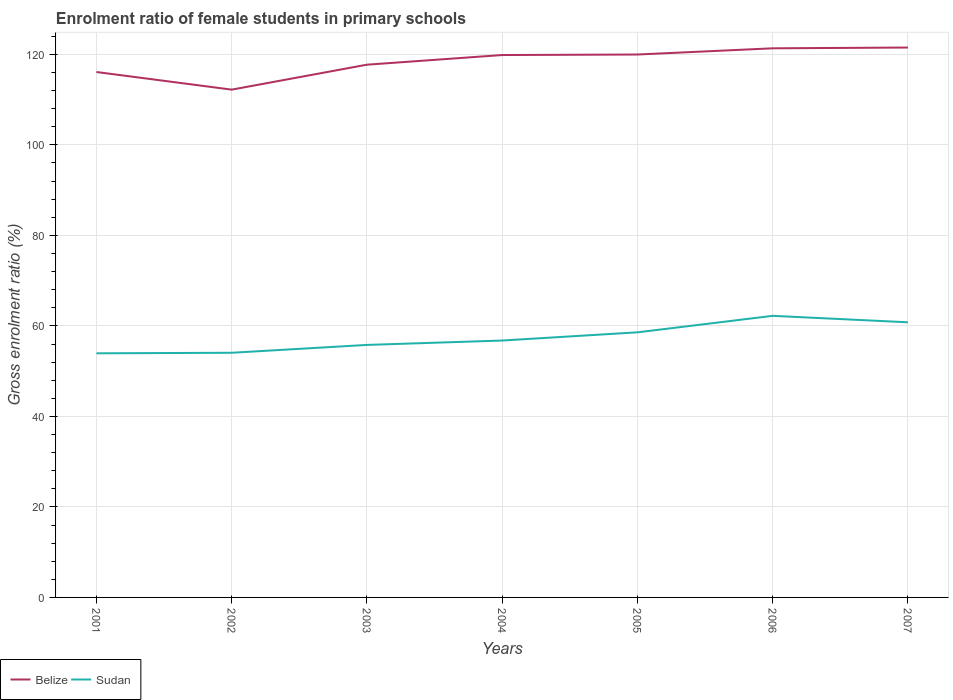Is the number of lines equal to the number of legend labels?
Provide a short and direct response. Yes. Across all years, what is the maximum enrolment ratio of female students in primary schools in Sudan?
Your response must be concise. 53.94. What is the total enrolment ratio of female students in primary schools in Sudan in the graph?
Keep it short and to the point. -4.52. What is the difference between the highest and the second highest enrolment ratio of female students in primary schools in Belize?
Your answer should be compact. 9.3. Is the enrolment ratio of female students in primary schools in Sudan strictly greater than the enrolment ratio of female students in primary schools in Belize over the years?
Your response must be concise. Yes. How many lines are there?
Keep it short and to the point. 2. Are the values on the major ticks of Y-axis written in scientific E-notation?
Offer a terse response. No. What is the title of the graph?
Your answer should be very brief. Enrolment ratio of female students in primary schools. What is the label or title of the X-axis?
Offer a terse response. Years. What is the Gross enrolment ratio (%) in Belize in 2001?
Keep it short and to the point. 116.11. What is the Gross enrolment ratio (%) of Sudan in 2001?
Keep it short and to the point. 53.94. What is the Gross enrolment ratio (%) in Belize in 2002?
Ensure brevity in your answer.  112.21. What is the Gross enrolment ratio (%) of Sudan in 2002?
Provide a short and direct response. 54.06. What is the Gross enrolment ratio (%) in Belize in 2003?
Your answer should be compact. 117.72. What is the Gross enrolment ratio (%) in Sudan in 2003?
Give a very brief answer. 55.8. What is the Gross enrolment ratio (%) of Belize in 2004?
Your response must be concise. 119.86. What is the Gross enrolment ratio (%) in Sudan in 2004?
Offer a terse response. 56.77. What is the Gross enrolment ratio (%) of Belize in 2005?
Give a very brief answer. 119.97. What is the Gross enrolment ratio (%) of Sudan in 2005?
Give a very brief answer. 58.58. What is the Gross enrolment ratio (%) of Belize in 2006?
Provide a succinct answer. 121.34. What is the Gross enrolment ratio (%) in Sudan in 2006?
Your answer should be very brief. 62.23. What is the Gross enrolment ratio (%) in Belize in 2007?
Offer a very short reply. 121.51. What is the Gross enrolment ratio (%) of Sudan in 2007?
Your response must be concise. 60.8. Across all years, what is the maximum Gross enrolment ratio (%) of Belize?
Your answer should be very brief. 121.51. Across all years, what is the maximum Gross enrolment ratio (%) of Sudan?
Your response must be concise. 62.23. Across all years, what is the minimum Gross enrolment ratio (%) in Belize?
Keep it short and to the point. 112.21. Across all years, what is the minimum Gross enrolment ratio (%) in Sudan?
Provide a short and direct response. 53.94. What is the total Gross enrolment ratio (%) in Belize in the graph?
Ensure brevity in your answer.  828.72. What is the total Gross enrolment ratio (%) in Sudan in the graph?
Your answer should be compact. 402.18. What is the difference between the Gross enrolment ratio (%) in Belize in 2001 and that in 2002?
Keep it short and to the point. 3.9. What is the difference between the Gross enrolment ratio (%) of Sudan in 2001 and that in 2002?
Your response must be concise. -0.12. What is the difference between the Gross enrolment ratio (%) of Belize in 2001 and that in 2003?
Make the answer very short. -1.62. What is the difference between the Gross enrolment ratio (%) in Sudan in 2001 and that in 2003?
Provide a succinct answer. -1.86. What is the difference between the Gross enrolment ratio (%) in Belize in 2001 and that in 2004?
Give a very brief answer. -3.75. What is the difference between the Gross enrolment ratio (%) of Sudan in 2001 and that in 2004?
Make the answer very short. -2.83. What is the difference between the Gross enrolment ratio (%) in Belize in 2001 and that in 2005?
Your response must be concise. -3.86. What is the difference between the Gross enrolment ratio (%) of Sudan in 2001 and that in 2005?
Give a very brief answer. -4.64. What is the difference between the Gross enrolment ratio (%) of Belize in 2001 and that in 2006?
Your answer should be very brief. -5.23. What is the difference between the Gross enrolment ratio (%) of Sudan in 2001 and that in 2006?
Provide a short and direct response. -8.28. What is the difference between the Gross enrolment ratio (%) of Belize in 2001 and that in 2007?
Your response must be concise. -5.41. What is the difference between the Gross enrolment ratio (%) in Sudan in 2001 and that in 2007?
Offer a terse response. -6.86. What is the difference between the Gross enrolment ratio (%) in Belize in 2002 and that in 2003?
Provide a short and direct response. -5.51. What is the difference between the Gross enrolment ratio (%) in Sudan in 2002 and that in 2003?
Keep it short and to the point. -1.73. What is the difference between the Gross enrolment ratio (%) of Belize in 2002 and that in 2004?
Your answer should be compact. -7.65. What is the difference between the Gross enrolment ratio (%) in Sudan in 2002 and that in 2004?
Keep it short and to the point. -2.7. What is the difference between the Gross enrolment ratio (%) in Belize in 2002 and that in 2005?
Offer a terse response. -7.76. What is the difference between the Gross enrolment ratio (%) of Sudan in 2002 and that in 2005?
Your response must be concise. -4.52. What is the difference between the Gross enrolment ratio (%) of Belize in 2002 and that in 2006?
Ensure brevity in your answer.  -9.13. What is the difference between the Gross enrolment ratio (%) in Sudan in 2002 and that in 2006?
Your answer should be very brief. -8.16. What is the difference between the Gross enrolment ratio (%) of Belize in 2002 and that in 2007?
Offer a very short reply. -9.3. What is the difference between the Gross enrolment ratio (%) of Sudan in 2002 and that in 2007?
Your answer should be compact. -6.73. What is the difference between the Gross enrolment ratio (%) of Belize in 2003 and that in 2004?
Your answer should be very brief. -2.14. What is the difference between the Gross enrolment ratio (%) in Sudan in 2003 and that in 2004?
Offer a terse response. -0.97. What is the difference between the Gross enrolment ratio (%) in Belize in 2003 and that in 2005?
Give a very brief answer. -2.25. What is the difference between the Gross enrolment ratio (%) in Sudan in 2003 and that in 2005?
Give a very brief answer. -2.78. What is the difference between the Gross enrolment ratio (%) in Belize in 2003 and that in 2006?
Your answer should be very brief. -3.62. What is the difference between the Gross enrolment ratio (%) of Sudan in 2003 and that in 2006?
Ensure brevity in your answer.  -6.43. What is the difference between the Gross enrolment ratio (%) of Belize in 2003 and that in 2007?
Make the answer very short. -3.79. What is the difference between the Gross enrolment ratio (%) of Sudan in 2003 and that in 2007?
Give a very brief answer. -5. What is the difference between the Gross enrolment ratio (%) in Belize in 2004 and that in 2005?
Provide a succinct answer. -0.11. What is the difference between the Gross enrolment ratio (%) of Sudan in 2004 and that in 2005?
Offer a terse response. -1.81. What is the difference between the Gross enrolment ratio (%) of Belize in 2004 and that in 2006?
Provide a succinct answer. -1.48. What is the difference between the Gross enrolment ratio (%) of Sudan in 2004 and that in 2006?
Keep it short and to the point. -5.46. What is the difference between the Gross enrolment ratio (%) of Belize in 2004 and that in 2007?
Your response must be concise. -1.65. What is the difference between the Gross enrolment ratio (%) of Sudan in 2004 and that in 2007?
Offer a very short reply. -4.03. What is the difference between the Gross enrolment ratio (%) of Belize in 2005 and that in 2006?
Keep it short and to the point. -1.37. What is the difference between the Gross enrolment ratio (%) of Sudan in 2005 and that in 2006?
Provide a short and direct response. -3.65. What is the difference between the Gross enrolment ratio (%) of Belize in 2005 and that in 2007?
Make the answer very short. -1.54. What is the difference between the Gross enrolment ratio (%) of Sudan in 2005 and that in 2007?
Your response must be concise. -2.22. What is the difference between the Gross enrolment ratio (%) of Belize in 2006 and that in 2007?
Your answer should be very brief. -0.17. What is the difference between the Gross enrolment ratio (%) in Sudan in 2006 and that in 2007?
Offer a very short reply. 1.43. What is the difference between the Gross enrolment ratio (%) of Belize in 2001 and the Gross enrolment ratio (%) of Sudan in 2002?
Provide a succinct answer. 62.04. What is the difference between the Gross enrolment ratio (%) in Belize in 2001 and the Gross enrolment ratio (%) in Sudan in 2003?
Your answer should be compact. 60.31. What is the difference between the Gross enrolment ratio (%) of Belize in 2001 and the Gross enrolment ratio (%) of Sudan in 2004?
Keep it short and to the point. 59.34. What is the difference between the Gross enrolment ratio (%) of Belize in 2001 and the Gross enrolment ratio (%) of Sudan in 2005?
Keep it short and to the point. 57.53. What is the difference between the Gross enrolment ratio (%) of Belize in 2001 and the Gross enrolment ratio (%) of Sudan in 2006?
Provide a succinct answer. 53.88. What is the difference between the Gross enrolment ratio (%) in Belize in 2001 and the Gross enrolment ratio (%) in Sudan in 2007?
Keep it short and to the point. 55.31. What is the difference between the Gross enrolment ratio (%) of Belize in 2002 and the Gross enrolment ratio (%) of Sudan in 2003?
Keep it short and to the point. 56.41. What is the difference between the Gross enrolment ratio (%) in Belize in 2002 and the Gross enrolment ratio (%) in Sudan in 2004?
Provide a short and direct response. 55.44. What is the difference between the Gross enrolment ratio (%) of Belize in 2002 and the Gross enrolment ratio (%) of Sudan in 2005?
Provide a succinct answer. 53.63. What is the difference between the Gross enrolment ratio (%) of Belize in 2002 and the Gross enrolment ratio (%) of Sudan in 2006?
Ensure brevity in your answer.  49.98. What is the difference between the Gross enrolment ratio (%) in Belize in 2002 and the Gross enrolment ratio (%) in Sudan in 2007?
Provide a short and direct response. 51.41. What is the difference between the Gross enrolment ratio (%) of Belize in 2003 and the Gross enrolment ratio (%) of Sudan in 2004?
Your answer should be very brief. 60.95. What is the difference between the Gross enrolment ratio (%) in Belize in 2003 and the Gross enrolment ratio (%) in Sudan in 2005?
Ensure brevity in your answer.  59.14. What is the difference between the Gross enrolment ratio (%) of Belize in 2003 and the Gross enrolment ratio (%) of Sudan in 2006?
Make the answer very short. 55.5. What is the difference between the Gross enrolment ratio (%) in Belize in 2003 and the Gross enrolment ratio (%) in Sudan in 2007?
Offer a very short reply. 56.92. What is the difference between the Gross enrolment ratio (%) of Belize in 2004 and the Gross enrolment ratio (%) of Sudan in 2005?
Provide a short and direct response. 61.28. What is the difference between the Gross enrolment ratio (%) of Belize in 2004 and the Gross enrolment ratio (%) of Sudan in 2006?
Provide a short and direct response. 57.63. What is the difference between the Gross enrolment ratio (%) of Belize in 2004 and the Gross enrolment ratio (%) of Sudan in 2007?
Keep it short and to the point. 59.06. What is the difference between the Gross enrolment ratio (%) of Belize in 2005 and the Gross enrolment ratio (%) of Sudan in 2006?
Your answer should be compact. 57.74. What is the difference between the Gross enrolment ratio (%) of Belize in 2005 and the Gross enrolment ratio (%) of Sudan in 2007?
Keep it short and to the point. 59.17. What is the difference between the Gross enrolment ratio (%) of Belize in 2006 and the Gross enrolment ratio (%) of Sudan in 2007?
Offer a very short reply. 60.54. What is the average Gross enrolment ratio (%) in Belize per year?
Provide a succinct answer. 118.39. What is the average Gross enrolment ratio (%) in Sudan per year?
Ensure brevity in your answer.  57.45. In the year 2001, what is the difference between the Gross enrolment ratio (%) in Belize and Gross enrolment ratio (%) in Sudan?
Provide a succinct answer. 62.16. In the year 2002, what is the difference between the Gross enrolment ratio (%) in Belize and Gross enrolment ratio (%) in Sudan?
Provide a succinct answer. 58.15. In the year 2003, what is the difference between the Gross enrolment ratio (%) of Belize and Gross enrolment ratio (%) of Sudan?
Your answer should be compact. 61.92. In the year 2004, what is the difference between the Gross enrolment ratio (%) of Belize and Gross enrolment ratio (%) of Sudan?
Ensure brevity in your answer.  63.09. In the year 2005, what is the difference between the Gross enrolment ratio (%) of Belize and Gross enrolment ratio (%) of Sudan?
Keep it short and to the point. 61.39. In the year 2006, what is the difference between the Gross enrolment ratio (%) in Belize and Gross enrolment ratio (%) in Sudan?
Offer a very short reply. 59.11. In the year 2007, what is the difference between the Gross enrolment ratio (%) of Belize and Gross enrolment ratio (%) of Sudan?
Make the answer very short. 60.71. What is the ratio of the Gross enrolment ratio (%) in Belize in 2001 to that in 2002?
Keep it short and to the point. 1.03. What is the ratio of the Gross enrolment ratio (%) in Sudan in 2001 to that in 2002?
Your response must be concise. 1. What is the ratio of the Gross enrolment ratio (%) in Belize in 2001 to that in 2003?
Your answer should be compact. 0.99. What is the ratio of the Gross enrolment ratio (%) of Sudan in 2001 to that in 2003?
Your response must be concise. 0.97. What is the ratio of the Gross enrolment ratio (%) in Belize in 2001 to that in 2004?
Make the answer very short. 0.97. What is the ratio of the Gross enrolment ratio (%) of Sudan in 2001 to that in 2004?
Give a very brief answer. 0.95. What is the ratio of the Gross enrolment ratio (%) of Belize in 2001 to that in 2005?
Provide a short and direct response. 0.97. What is the ratio of the Gross enrolment ratio (%) of Sudan in 2001 to that in 2005?
Give a very brief answer. 0.92. What is the ratio of the Gross enrolment ratio (%) of Belize in 2001 to that in 2006?
Keep it short and to the point. 0.96. What is the ratio of the Gross enrolment ratio (%) in Sudan in 2001 to that in 2006?
Offer a terse response. 0.87. What is the ratio of the Gross enrolment ratio (%) in Belize in 2001 to that in 2007?
Provide a succinct answer. 0.96. What is the ratio of the Gross enrolment ratio (%) of Sudan in 2001 to that in 2007?
Your response must be concise. 0.89. What is the ratio of the Gross enrolment ratio (%) in Belize in 2002 to that in 2003?
Give a very brief answer. 0.95. What is the ratio of the Gross enrolment ratio (%) of Sudan in 2002 to that in 2003?
Give a very brief answer. 0.97. What is the ratio of the Gross enrolment ratio (%) in Belize in 2002 to that in 2004?
Provide a short and direct response. 0.94. What is the ratio of the Gross enrolment ratio (%) in Sudan in 2002 to that in 2004?
Ensure brevity in your answer.  0.95. What is the ratio of the Gross enrolment ratio (%) in Belize in 2002 to that in 2005?
Provide a succinct answer. 0.94. What is the ratio of the Gross enrolment ratio (%) of Sudan in 2002 to that in 2005?
Offer a very short reply. 0.92. What is the ratio of the Gross enrolment ratio (%) of Belize in 2002 to that in 2006?
Your answer should be very brief. 0.92. What is the ratio of the Gross enrolment ratio (%) of Sudan in 2002 to that in 2006?
Make the answer very short. 0.87. What is the ratio of the Gross enrolment ratio (%) in Belize in 2002 to that in 2007?
Offer a terse response. 0.92. What is the ratio of the Gross enrolment ratio (%) of Sudan in 2002 to that in 2007?
Your answer should be very brief. 0.89. What is the ratio of the Gross enrolment ratio (%) of Belize in 2003 to that in 2004?
Ensure brevity in your answer.  0.98. What is the ratio of the Gross enrolment ratio (%) in Sudan in 2003 to that in 2004?
Provide a succinct answer. 0.98. What is the ratio of the Gross enrolment ratio (%) in Belize in 2003 to that in 2005?
Provide a succinct answer. 0.98. What is the ratio of the Gross enrolment ratio (%) in Sudan in 2003 to that in 2005?
Provide a short and direct response. 0.95. What is the ratio of the Gross enrolment ratio (%) of Belize in 2003 to that in 2006?
Provide a succinct answer. 0.97. What is the ratio of the Gross enrolment ratio (%) of Sudan in 2003 to that in 2006?
Your response must be concise. 0.9. What is the ratio of the Gross enrolment ratio (%) in Belize in 2003 to that in 2007?
Give a very brief answer. 0.97. What is the ratio of the Gross enrolment ratio (%) of Sudan in 2003 to that in 2007?
Make the answer very short. 0.92. What is the ratio of the Gross enrolment ratio (%) in Belize in 2004 to that in 2005?
Offer a very short reply. 1. What is the ratio of the Gross enrolment ratio (%) of Sudan in 2004 to that in 2005?
Your answer should be compact. 0.97. What is the ratio of the Gross enrolment ratio (%) of Sudan in 2004 to that in 2006?
Your answer should be compact. 0.91. What is the ratio of the Gross enrolment ratio (%) of Belize in 2004 to that in 2007?
Give a very brief answer. 0.99. What is the ratio of the Gross enrolment ratio (%) of Sudan in 2004 to that in 2007?
Offer a very short reply. 0.93. What is the ratio of the Gross enrolment ratio (%) of Belize in 2005 to that in 2006?
Provide a short and direct response. 0.99. What is the ratio of the Gross enrolment ratio (%) in Sudan in 2005 to that in 2006?
Make the answer very short. 0.94. What is the ratio of the Gross enrolment ratio (%) in Belize in 2005 to that in 2007?
Ensure brevity in your answer.  0.99. What is the ratio of the Gross enrolment ratio (%) in Sudan in 2005 to that in 2007?
Make the answer very short. 0.96. What is the ratio of the Gross enrolment ratio (%) in Belize in 2006 to that in 2007?
Give a very brief answer. 1. What is the ratio of the Gross enrolment ratio (%) in Sudan in 2006 to that in 2007?
Your response must be concise. 1.02. What is the difference between the highest and the second highest Gross enrolment ratio (%) in Belize?
Keep it short and to the point. 0.17. What is the difference between the highest and the second highest Gross enrolment ratio (%) of Sudan?
Give a very brief answer. 1.43. What is the difference between the highest and the lowest Gross enrolment ratio (%) in Belize?
Give a very brief answer. 9.3. What is the difference between the highest and the lowest Gross enrolment ratio (%) in Sudan?
Offer a terse response. 8.28. 